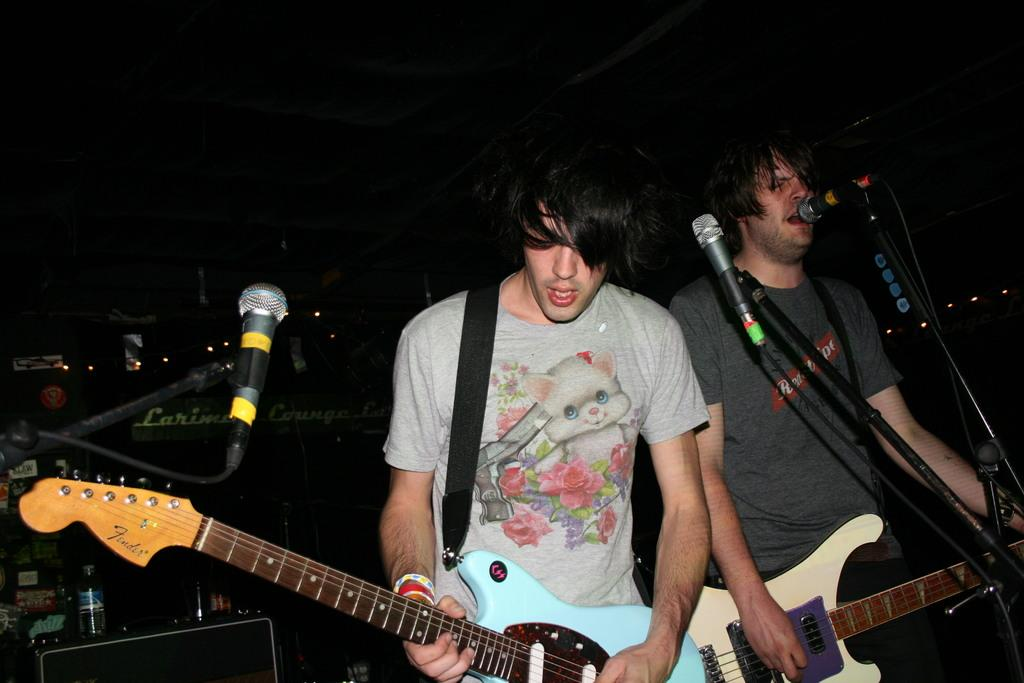How many people are in the image? There are two men in the image. What are the men holding in the image? The men are holding guitars. What are the men doing with the guitars? The men are playing the guitars. What equipment do the men have for amplifying their voices? Both men have microphones. What are the microphones attached to in the image? There are microphone stands in front of the men. What activity are the men engaged in? The men are singing. Where is the shelf with the eggnog located in the image? There is no shelf or eggnog present in the image. What type of discovery can be seen in the image? There is no discovery depicted in the image; it features two men playing guitars and singing. 